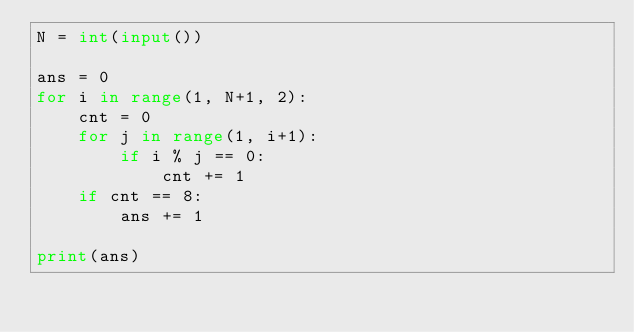<code> <loc_0><loc_0><loc_500><loc_500><_Python_>N = int(input())
 
ans = 0
for i in range(1, N+1, 2):
    cnt = 0
    for j in range(1, i+1):
        if i % j == 0:
            cnt += 1
    if cnt == 8:
        ans += 1

print(ans)
</code> 